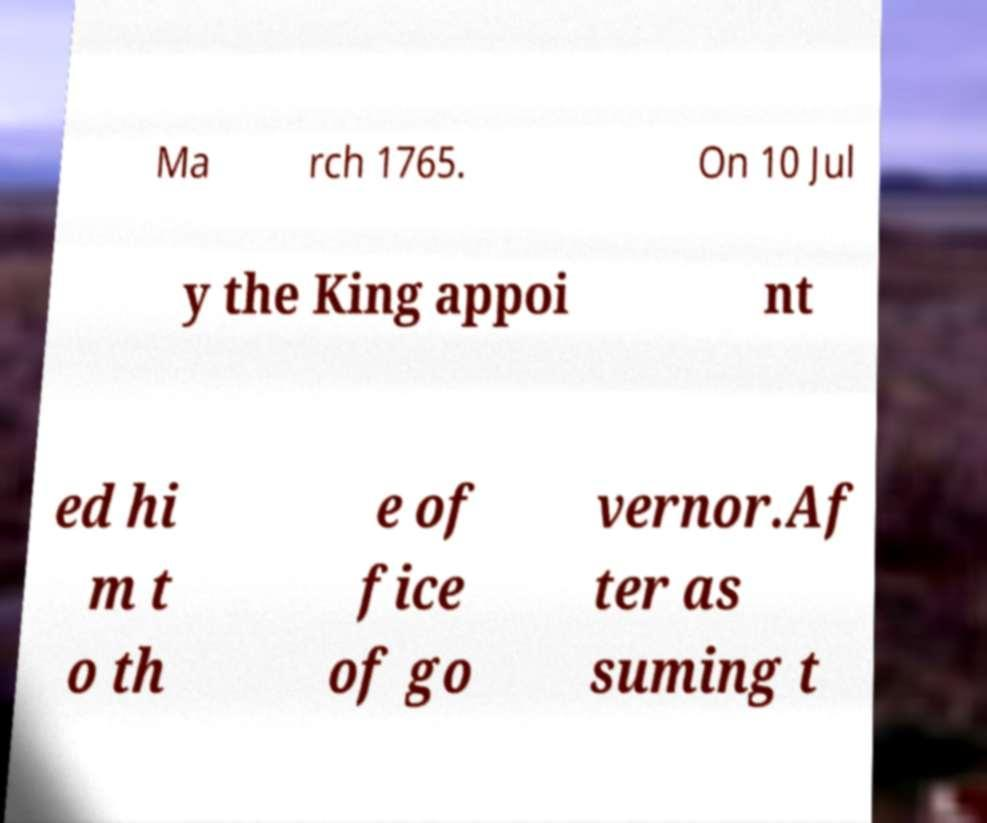Can you accurately transcribe the text from the provided image for me? Ma rch 1765. On 10 Jul y the King appoi nt ed hi m t o th e of fice of go vernor.Af ter as suming t 